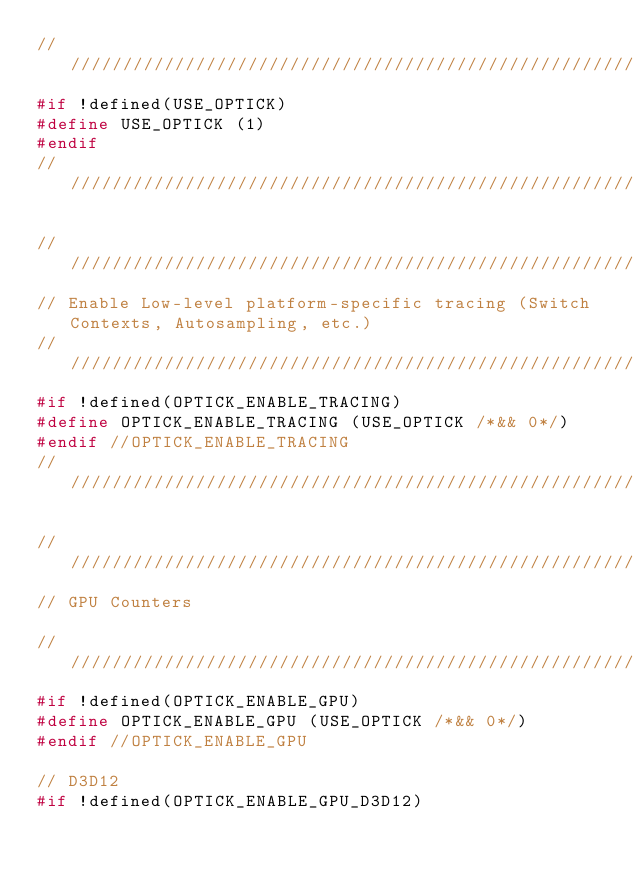<code> <loc_0><loc_0><loc_500><loc_500><_C_>////////////////////////////////////////////////////////////////////////////////////////////////////////////////////////////////
#if !defined(USE_OPTICK)
#define USE_OPTICK (1)
#endif
////////////////////////////////////////////////////////////////////////////////////////////////////////////////////////////////

////////////////////////////////////////////////////////////////////////////////////////////////////////////////////////////////
// Enable Low-level platform-specific tracing (Switch Contexts, Autosampling, etc.)											  
////////////////////////////////////////////////////////////////////////////////////////////////////////////////////////////////
#if !defined(OPTICK_ENABLE_TRACING)
#define OPTICK_ENABLE_TRACING (USE_OPTICK /*&& 0*/)
#endif //OPTICK_ENABLE_TRACING
////////////////////////////////////////////////////////////////////////////////////////////////////////////////////////////////

////////////////////////////////////////////////////////////////////////////////////////////////////////////////////////////////
// GPU Counters																										  
////////////////////////////////////////////////////////////////////////////////////////////////////////////////////////////////
#if !defined(OPTICK_ENABLE_GPU)
#define OPTICK_ENABLE_GPU (USE_OPTICK /*&& 0*/)
#endif //OPTICK_ENABLE_GPU

// D3D12
#if !defined(OPTICK_ENABLE_GPU_D3D12)</code> 